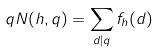<formula> <loc_0><loc_0><loc_500><loc_500>q N ( h , q ) = \sum _ { d | q } f _ { h } ( d )</formula> 